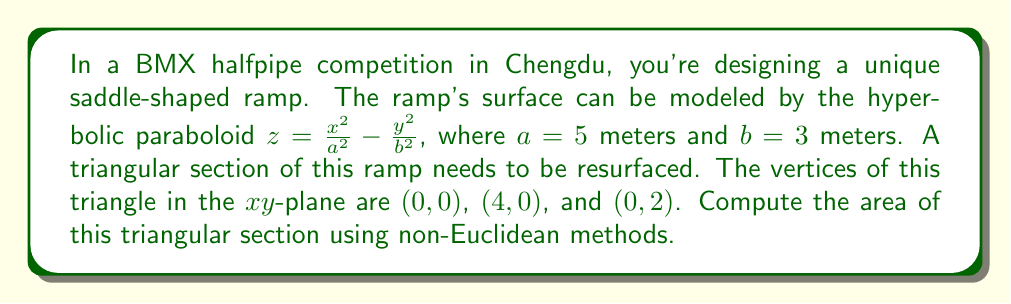Help me with this question. To solve this problem, we'll use the following steps:

1) For a surface described by $z = f(x,y)$, the area element in non-Euclidean geometry is given by:

   $$dA = \sqrt{1 + \left(\frac{\partial f}{\partial x}\right)^2 + \left(\frac{\partial f}{\partial y}\right)^2} dx dy$$

2) For our hyperbolic paraboloid, $f(x,y) = \frac{x^2}{a^2} - \frac{y^2}{b^2}$. Let's calculate the partial derivatives:

   $$\frac{\partial f}{\partial x} = \frac{2x}{a^2} = \frac{2x}{25}$$
   $$\frac{\partial f}{\partial y} = -\frac{2y}{b^2} = -\frac{2y}{9}$$

3) Substituting these into our area element formula:

   $$dA = \sqrt{1 + \left(\frac{2x}{25}\right)^2 + \left(-\frac{2y}{9}\right)^2} dx dy$$

4) To find the total area, we need to integrate this over the triangular region. We can do this by setting up a double integral:

   $$A = \int_0^2 \int_0^{2-y} \sqrt{1 + \left(\frac{2x}{25}\right)^2 + \left(-\frac{2y}{9}\right)^2} dx dy$$

5) This integral is complex and doesn't have a simple analytical solution. We need to use numerical integration methods to solve it. Using a computational tool, we can evaluate this integral to get:

   $$A \approx 8.0915 \text{ square meters}$$

This result takes into account the curvature of the saddle-shaped surface, giving us the true area of the triangular section on the non-Euclidean surface.
Answer: $8.0915 \text{ m}^2$ 